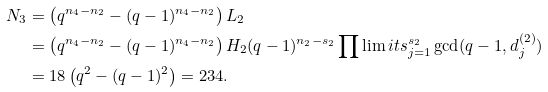Convert formula to latex. <formula><loc_0><loc_0><loc_500><loc_500>N _ { 3 } & = \left ( q ^ { n _ { 4 } - n _ { 2 } } - ( q - 1 ) ^ { n _ { 4 } - n _ { 2 } } \right ) L _ { 2 } \\ & = \left ( q ^ { n _ { 4 } - n _ { 2 } } - ( q - 1 ) ^ { n _ { 4 } - n _ { 2 } } \right ) H _ { 2 } ( q - 1 ) ^ { n _ { 2 } - s _ { 2 } } \prod \lim i t s _ { j = 1 } ^ { s _ { 2 } } \gcd ( q - 1 , d _ { j } ^ { ( 2 ) } ) \\ & = 1 8 \left ( q ^ { 2 } - ( q - 1 ) ^ { 2 } \right ) = 2 3 4 .</formula> 